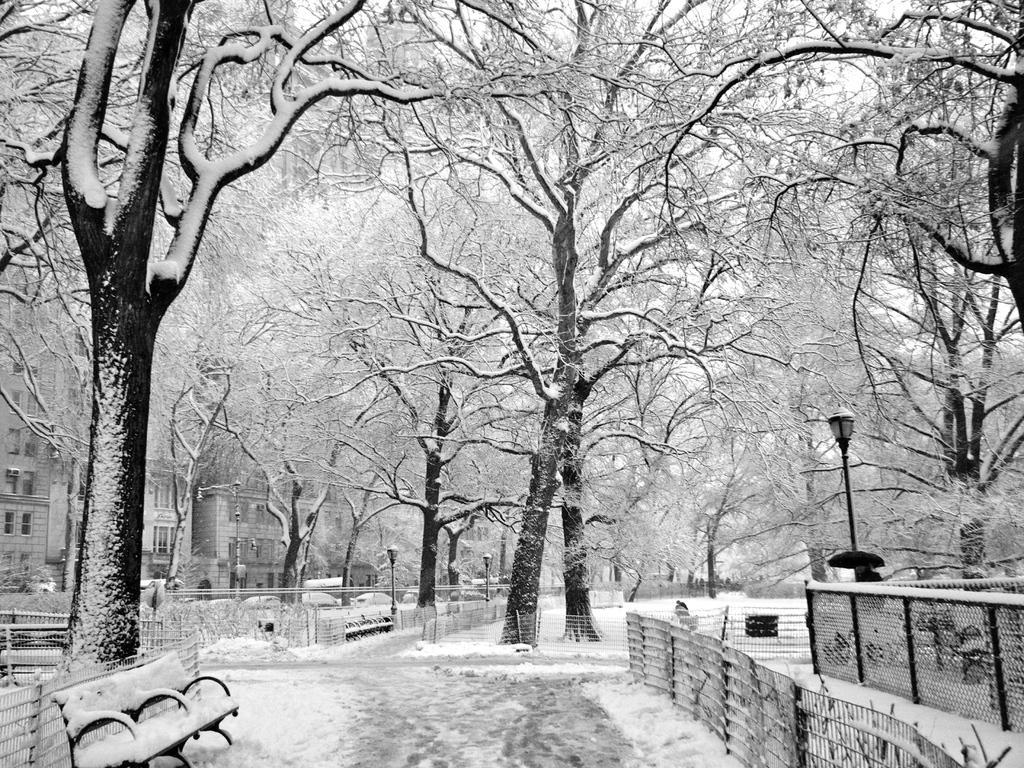Describe this image in one or two sentences. This is a black and white image. There are trees in the middle. There is a bench at the bottom. There are buildings on the left side. There is ice in this image. 